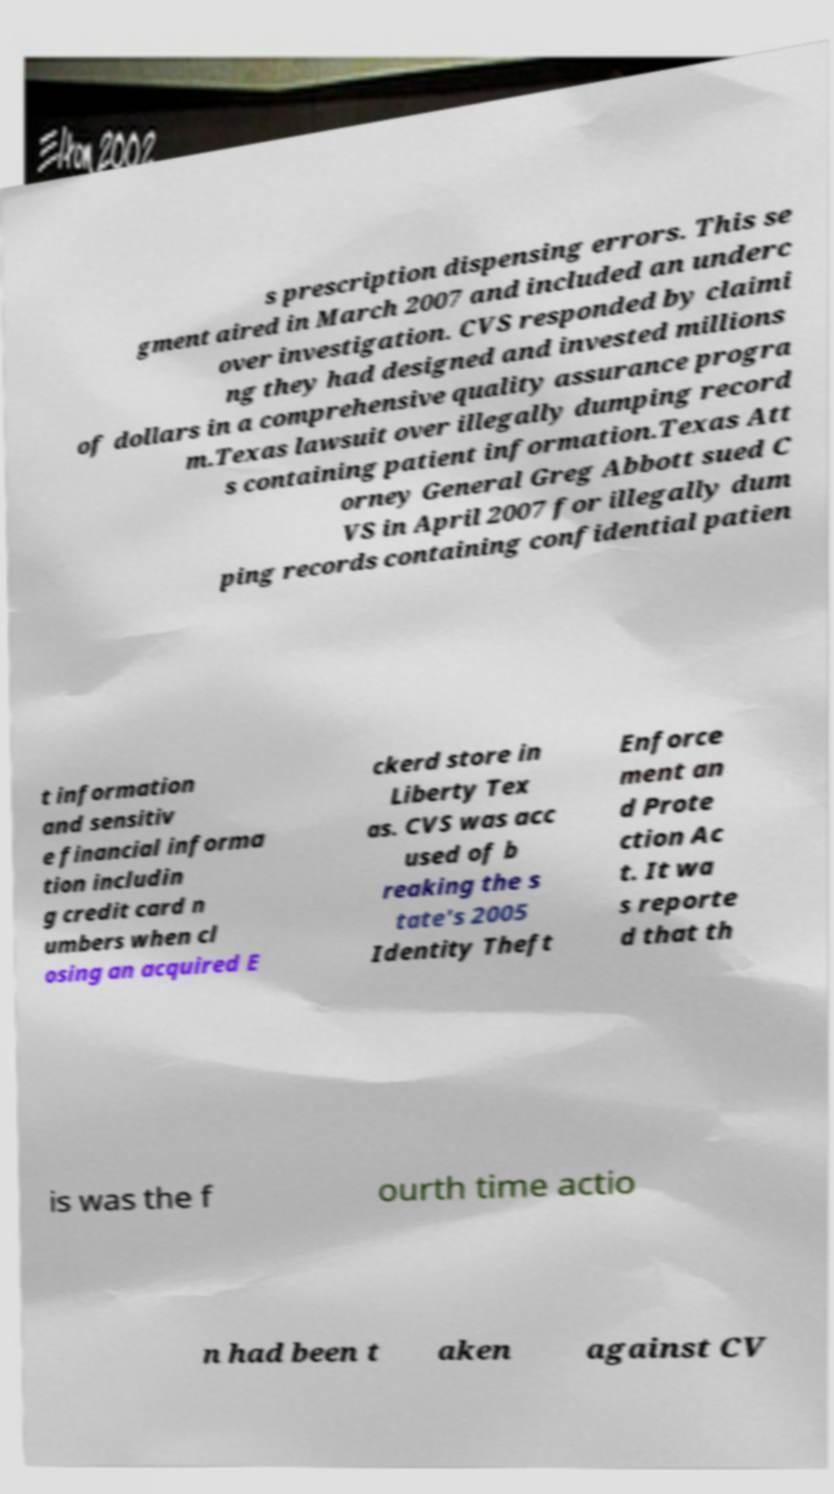Please read and relay the text visible in this image. What does it say? s prescription dispensing errors. This se gment aired in March 2007 and included an underc over investigation. CVS responded by claimi ng they had designed and invested millions of dollars in a comprehensive quality assurance progra m.Texas lawsuit over illegally dumping record s containing patient information.Texas Att orney General Greg Abbott sued C VS in April 2007 for illegally dum ping records containing confidential patien t information and sensitiv e financial informa tion includin g credit card n umbers when cl osing an acquired E ckerd store in Liberty Tex as. CVS was acc used of b reaking the s tate's 2005 Identity Theft Enforce ment an d Prote ction Ac t. It wa s reporte d that th is was the f ourth time actio n had been t aken against CV 